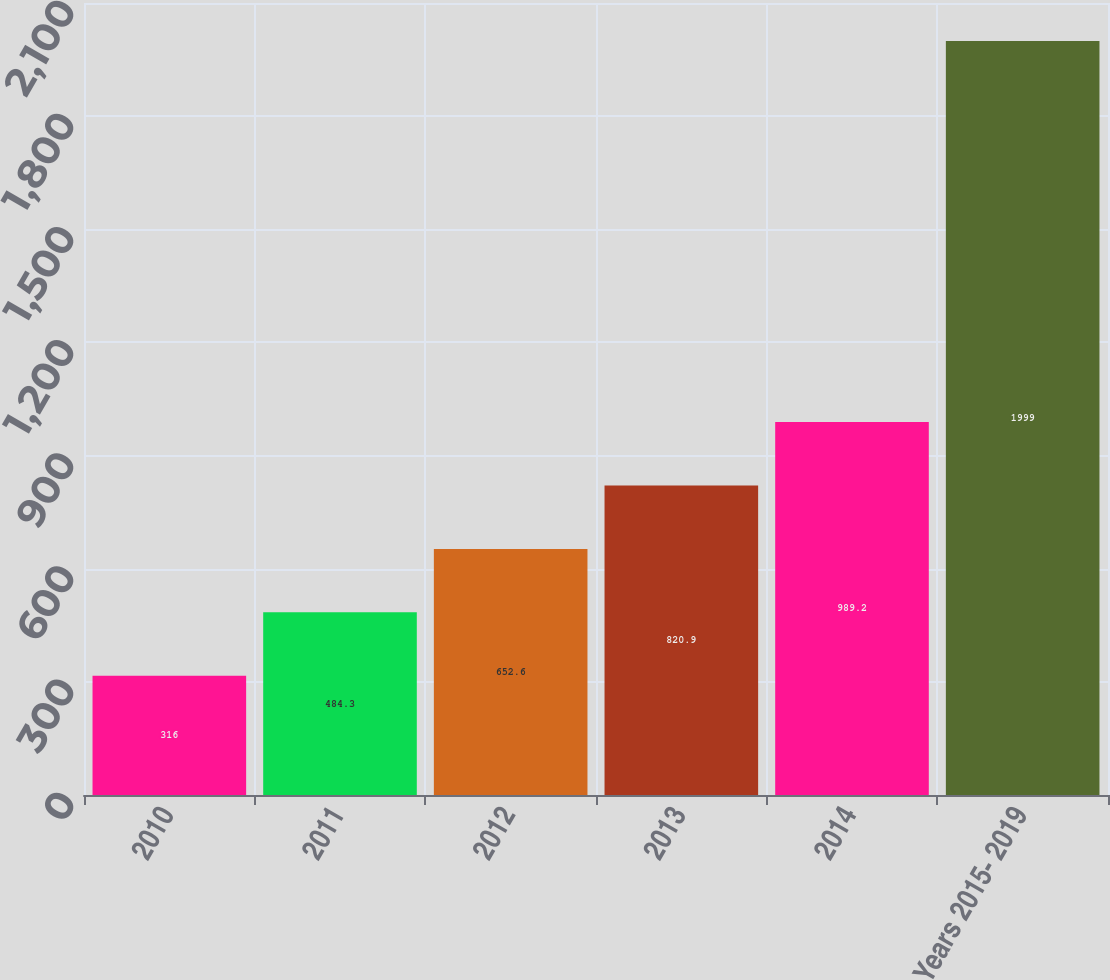Convert chart. <chart><loc_0><loc_0><loc_500><loc_500><bar_chart><fcel>2010<fcel>2011<fcel>2012<fcel>2013<fcel>2014<fcel>Years 2015- 2019<nl><fcel>316<fcel>484.3<fcel>652.6<fcel>820.9<fcel>989.2<fcel>1999<nl></chart> 